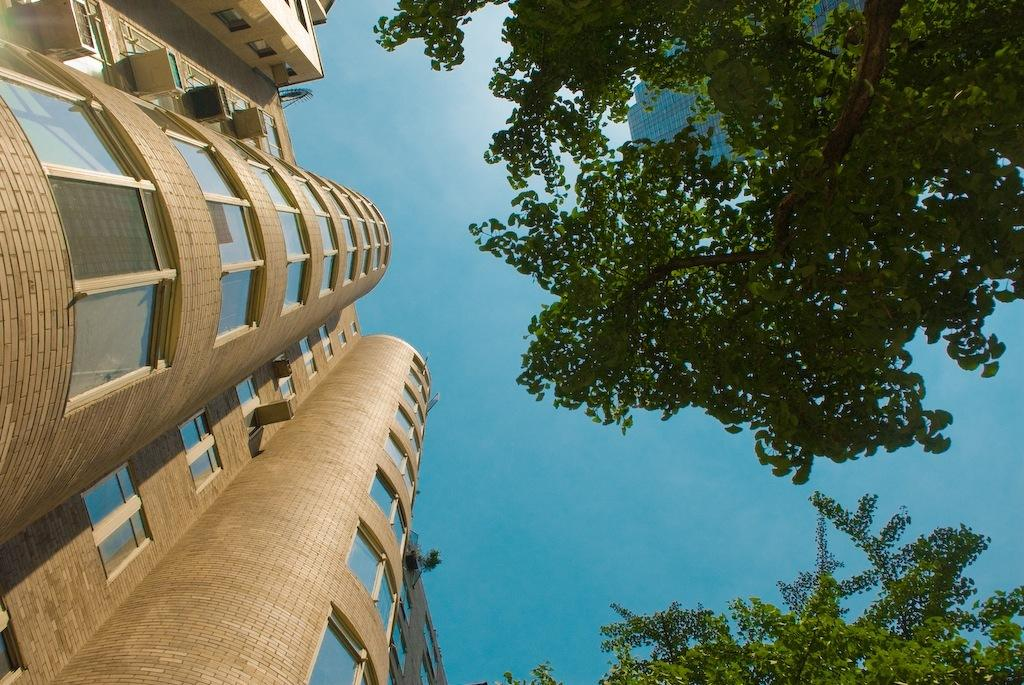What type of structure is present in the image? There is a building in the image. Can you describe the building's appearance? The building has multiple windows. What else can be seen in the image besides the building? There are trees visible in the image. Is there any other structure visible in the background? Yes, there is another building in the background of the image. What invention is being demonstrated in front of the building? There is no invention being demonstrated in front of the building in the image. What type of pot is visible on the roof of the building? There is no pot visible on the roof of the building in the image. 